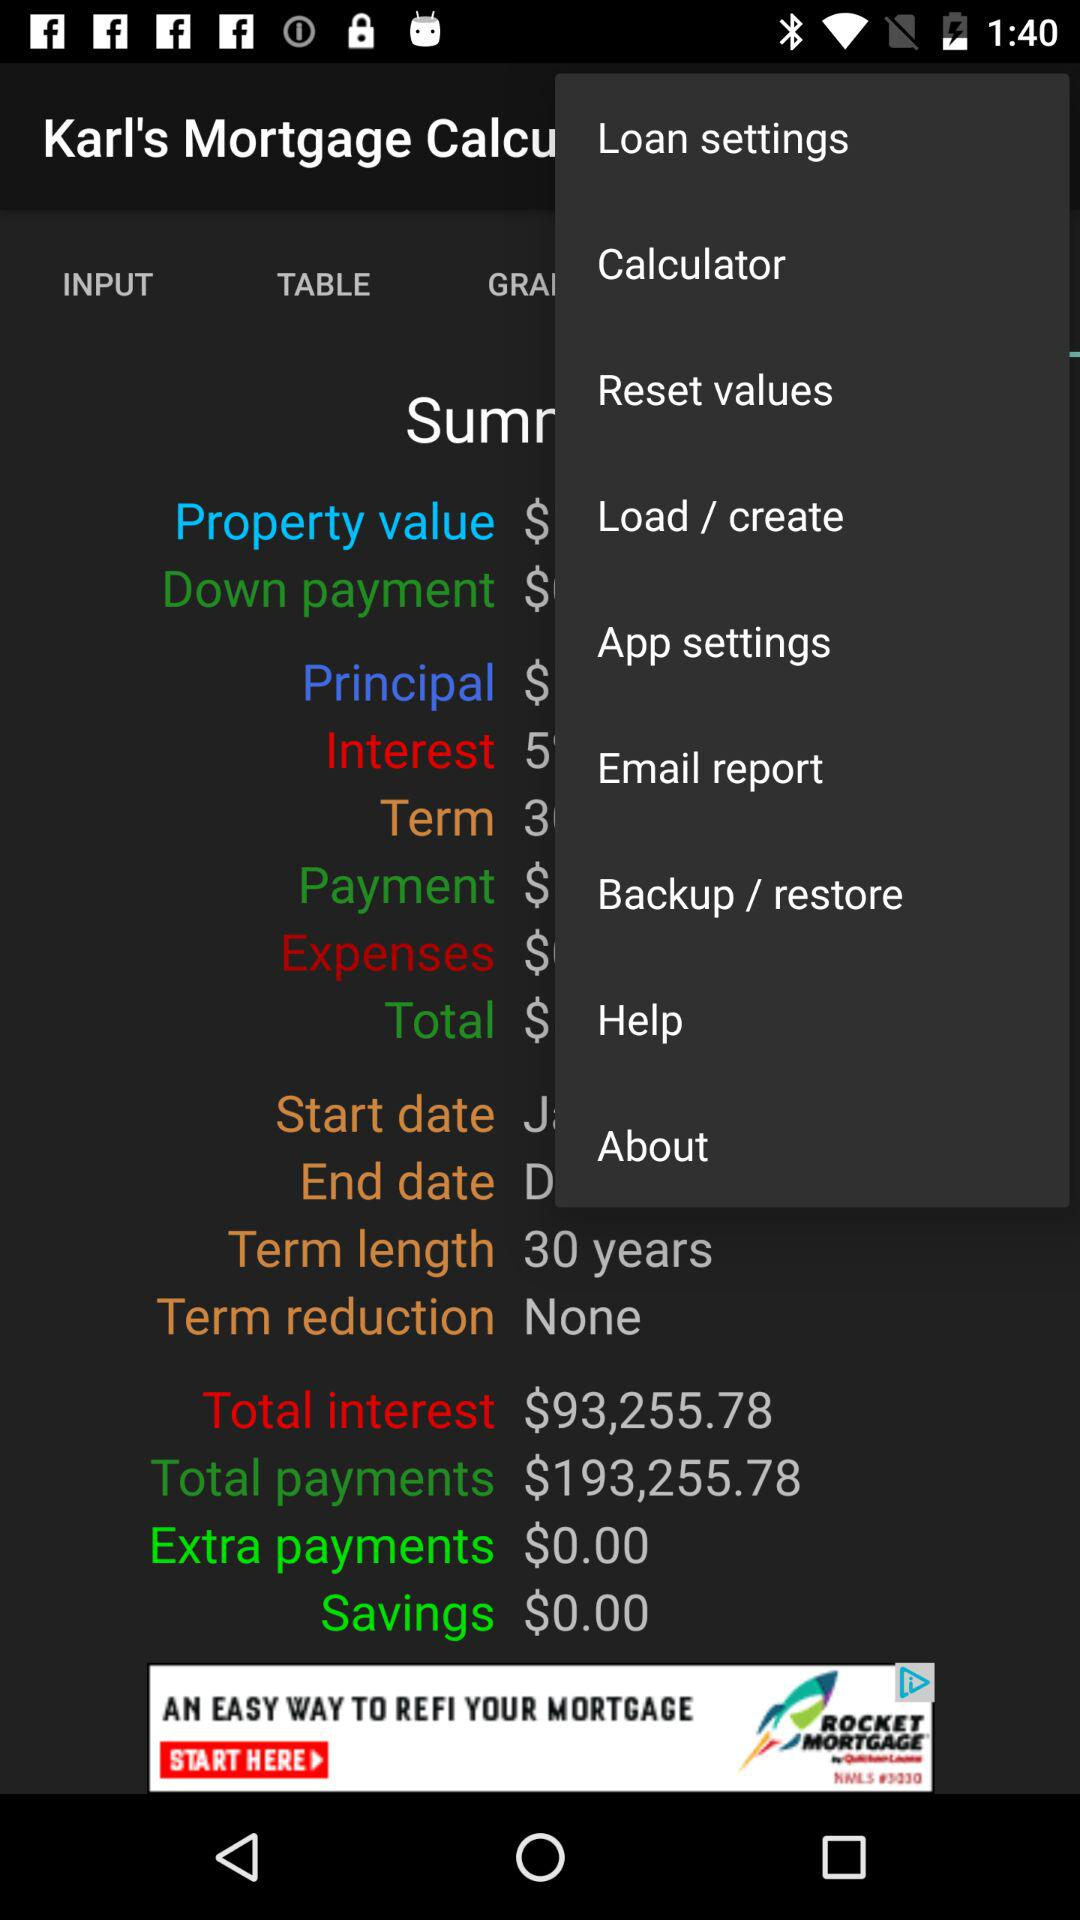How much is the total amount of principal and interest paid over the life of the loan?
Answer the question using a single word or phrase. $193,255.78 